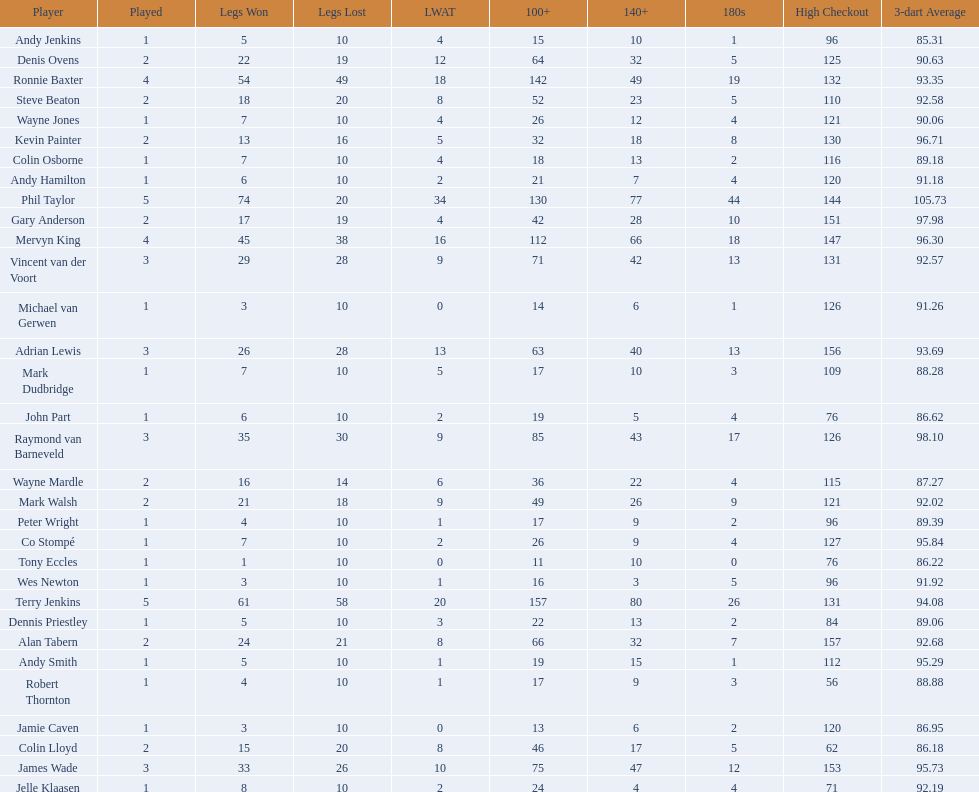What were the total number of legs won by ronnie baxter? 54. 